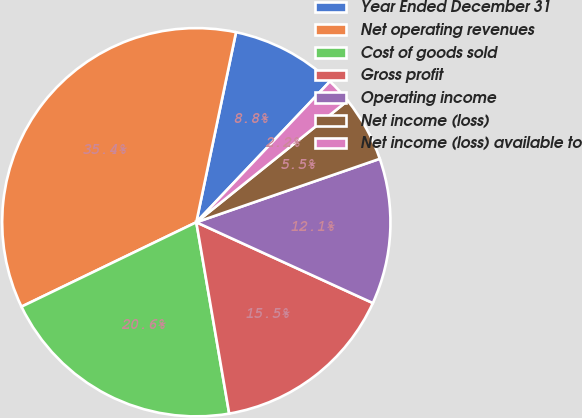Convert chart to OTSL. <chart><loc_0><loc_0><loc_500><loc_500><pie_chart><fcel>Year Ended December 31<fcel>Net operating revenues<fcel>Cost of goods sold<fcel>Gross profit<fcel>Operating income<fcel>Net income (loss)<fcel>Net income (loss) available to<nl><fcel>8.8%<fcel>35.44%<fcel>20.55%<fcel>15.46%<fcel>12.13%<fcel>5.47%<fcel>2.15%<nl></chart> 